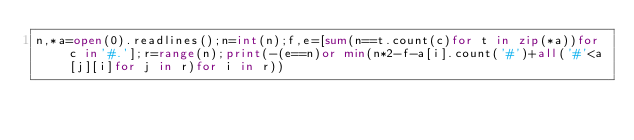<code> <loc_0><loc_0><loc_500><loc_500><_Python_>n,*a=open(0).readlines();n=int(n);f,e=[sum(n==t.count(c)for t in zip(*a))for c in'#.'];r=range(n);print(-(e==n)or min(n*2-f-a[i].count('#')+all('#'<a[j][i]for j in r)for i in r))</code> 